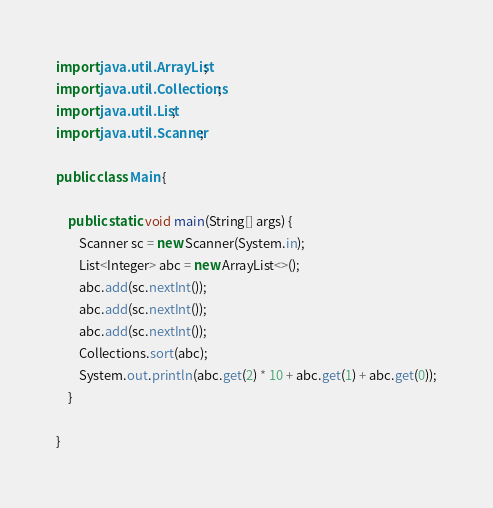<code> <loc_0><loc_0><loc_500><loc_500><_Java_>import java.util.ArrayList;
import java.util.Collections;
import java.util.List;
import java.util.Scanner;

public class Main {

    public static void main(String[] args) {
        Scanner sc = new Scanner(System.in);
        List<Integer> abc = new ArrayList<>();
        abc.add(sc.nextInt());
        abc.add(sc.nextInt());
        abc.add(sc.nextInt());
        Collections.sort(abc);
        System.out.println(abc.get(2) * 10 + abc.get(1) + abc.get(0));
    }

}
</code> 